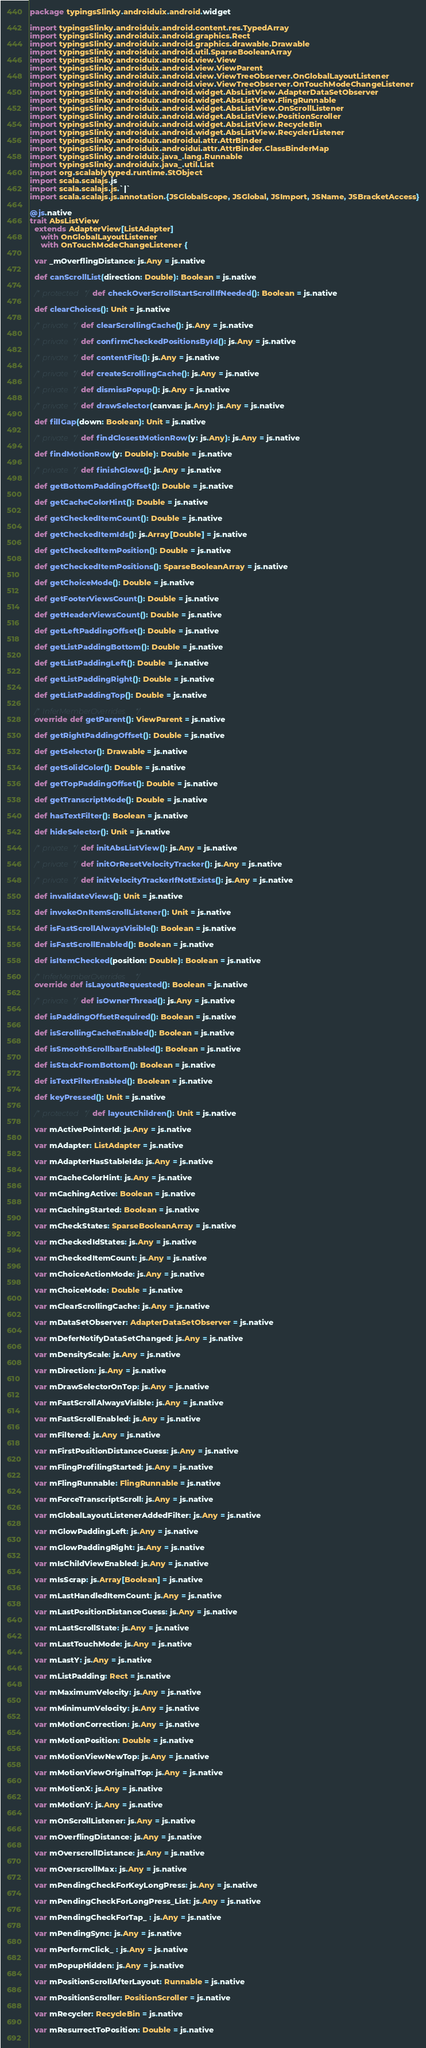Convert code to text. <code><loc_0><loc_0><loc_500><loc_500><_Scala_>package typingsSlinky.androiduix.android.widget

import typingsSlinky.androiduix.android.content.res.TypedArray
import typingsSlinky.androiduix.android.graphics.Rect
import typingsSlinky.androiduix.android.graphics.drawable.Drawable
import typingsSlinky.androiduix.android.util.SparseBooleanArray
import typingsSlinky.androiduix.android.view.View
import typingsSlinky.androiduix.android.view.ViewParent
import typingsSlinky.androiduix.android.view.ViewTreeObserver.OnGlobalLayoutListener
import typingsSlinky.androiduix.android.view.ViewTreeObserver.OnTouchModeChangeListener
import typingsSlinky.androiduix.android.widget.AbsListView.AdapterDataSetObserver
import typingsSlinky.androiduix.android.widget.AbsListView.FlingRunnable
import typingsSlinky.androiduix.android.widget.AbsListView.OnScrollListener
import typingsSlinky.androiduix.android.widget.AbsListView.PositionScroller
import typingsSlinky.androiduix.android.widget.AbsListView.RecycleBin
import typingsSlinky.androiduix.android.widget.AbsListView.RecyclerListener
import typingsSlinky.androiduix.androidui.attr.AttrBinder
import typingsSlinky.androiduix.androidui.attr.AttrBinder.ClassBinderMap
import typingsSlinky.androiduix.java_.lang.Runnable
import typingsSlinky.androiduix.java_.util.List
import org.scalablytyped.runtime.StObject
import scala.scalajs.js
import scala.scalajs.js.`|`
import scala.scalajs.js.annotation.{JSGlobalScope, JSGlobal, JSImport, JSName, JSBracketAccess}

@js.native
trait AbsListView
  extends AdapterView[ListAdapter]
     with OnGlobalLayoutListener
     with OnTouchModeChangeListener {
  
  var _mOverflingDistance: js.Any = js.native
  
  def canScrollList(direction: Double): Boolean = js.native
  
  /* protected */ def checkOverScrollStartScrollIfNeeded(): Boolean = js.native
  
  def clearChoices(): Unit = js.native
  
  /* private */ def clearScrollingCache(): js.Any = js.native
  
  /* private */ def confirmCheckedPositionsById(): js.Any = js.native
  
  /* private */ def contentFits(): js.Any = js.native
  
  /* private */ def createScrollingCache(): js.Any = js.native
  
  /* private */ def dismissPopup(): js.Any = js.native
  
  /* private */ def drawSelector(canvas: js.Any): js.Any = js.native
  
  def fillGap(down: Boolean): Unit = js.native
  
  /* private */ def findClosestMotionRow(y: js.Any): js.Any = js.native
  
  def findMotionRow(y: Double): Double = js.native
  
  /* private */ def finishGlows(): js.Any = js.native
  
  def getBottomPaddingOffset(): Double = js.native
  
  def getCacheColorHint(): Double = js.native
  
  def getCheckedItemCount(): Double = js.native
  
  def getCheckedItemIds(): js.Array[Double] = js.native
  
  def getCheckedItemPosition(): Double = js.native
  
  def getCheckedItemPositions(): SparseBooleanArray = js.native
  
  def getChoiceMode(): Double = js.native
  
  def getFooterViewsCount(): Double = js.native
  
  def getHeaderViewsCount(): Double = js.native
  
  def getLeftPaddingOffset(): Double = js.native
  
  def getListPaddingBottom(): Double = js.native
  
  def getListPaddingLeft(): Double = js.native
  
  def getListPaddingRight(): Double = js.native
  
  def getListPaddingTop(): Double = js.native
  
  /* InferMemberOverrides */
  override def getParent(): ViewParent = js.native
  
  def getRightPaddingOffset(): Double = js.native
  
  def getSelector(): Drawable = js.native
  
  def getSolidColor(): Double = js.native
  
  def getTopPaddingOffset(): Double = js.native
  
  def getTranscriptMode(): Double = js.native
  
  def hasTextFilter(): Boolean = js.native
  
  def hideSelector(): Unit = js.native
  
  /* private */ def initAbsListView(): js.Any = js.native
  
  /* private */ def initOrResetVelocityTracker(): js.Any = js.native
  
  /* private */ def initVelocityTrackerIfNotExists(): js.Any = js.native
  
  def invalidateViews(): Unit = js.native
  
  def invokeOnItemScrollListener(): Unit = js.native
  
  def isFastScrollAlwaysVisible(): Boolean = js.native
  
  def isFastScrollEnabled(): Boolean = js.native
  
  def isItemChecked(position: Double): Boolean = js.native
  
  /* InferMemberOverrides */
  override def isLayoutRequested(): Boolean = js.native
  
  /* private */ def isOwnerThread(): js.Any = js.native
  
  def isPaddingOffsetRequired(): Boolean = js.native
  
  def isScrollingCacheEnabled(): Boolean = js.native
  
  def isSmoothScrollbarEnabled(): Boolean = js.native
  
  def isStackFromBottom(): Boolean = js.native
  
  def isTextFilterEnabled(): Boolean = js.native
  
  def keyPressed(): Unit = js.native
  
  /* protected */ def layoutChildren(): Unit = js.native
  
  var mActivePointerId: js.Any = js.native
  
  var mAdapter: ListAdapter = js.native
  
  var mAdapterHasStableIds: js.Any = js.native
  
  var mCacheColorHint: js.Any = js.native
  
  var mCachingActive: Boolean = js.native
  
  var mCachingStarted: Boolean = js.native
  
  var mCheckStates: SparseBooleanArray = js.native
  
  var mCheckedIdStates: js.Any = js.native
  
  var mCheckedItemCount: js.Any = js.native
  
  var mChoiceActionMode: js.Any = js.native
  
  var mChoiceMode: Double = js.native
  
  var mClearScrollingCache: js.Any = js.native
  
  var mDataSetObserver: AdapterDataSetObserver = js.native
  
  var mDeferNotifyDataSetChanged: js.Any = js.native
  
  var mDensityScale: js.Any = js.native
  
  var mDirection: js.Any = js.native
  
  var mDrawSelectorOnTop: js.Any = js.native
  
  var mFastScrollAlwaysVisible: js.Any = js.native
  
  var mFastScrollEnabled: js.Any = js.native
  
  var mFiltered: js.Any = js.native
  
  var mFirstPositionDistanceGuess: js.Any = js.native
  
  var mFlingProfilingStarted: js.Any = js.native
  
  var mFlingRunnable: FlingRunnable = js.native
  
  var mForceTranscriptScroll: js.Any = js.native
  
  var mGlobalLayoutListenerAddedFilter: js.Any = js.native
  
  var mGlowPaddingLeft: js.Any = js.native
  
  var mGlowPaddingRight: js.Any = js.native
  
  var mIsChildViewEnabled: js.Any = js.native
  
  var mIsScrap: js.Array[Boolean] = js.native
  
  var mLastHandledItemCount: js.Any = js.native
  
  var mLastPositionDistanceGuess: js.Any = js.native
  
  var mLastScrollState: js.Any = js.native
  
  var mLastTouchMode: js.Any = js.native
  
  var mLastY: js.Any = js.native
  
  var mListPadding: Rect = js.native
  
  var mMaximumVelocity: js.Any = js.native
  
  var mMinimumVelocity: js.Any = js.native
  
  var mMotionCorrection: js.Any = js.native
  
  var mMotionPosition: Double = js.native
  
  var mMotionViewNewTop: js.Any = js.native
  
  var mMotionViewOriginalTop: js.Any = js.native
  
  var mMotionX: js.Any = js.native
  
  var mMotionY: js.Any = js.native
  
  var mOnScrollListener: js.Any = js.native
  
  var mOverflingDistance: js.Any = js.native
  
  var mOverscrollDistance: js.Any = js.native
  
  var mOverscrollMax: js.Any = js.native
  
  var mPendingCheckForKeyLongPress: js.Any = js.native
  
  var mPendingCheckForLongPress_List: js.Any = js.native
  
  var mPendingCheckForTap_ : js.Any = js.native
  
  var mPendingSync: js.Any = js.native
  
  var mPerformClick_ : js.Any = js.native
  
  var mPopupHidden: js.Any = js.native
  
  var mPositionScrollAfterLayout: Runnable = js.native
  
  var mPositionScroller: PositionScroller = js.native
  
  var mRecycler: RecycleBin = js.native
  
  var mResurrectToPosition: Double = js.native
  </code> 